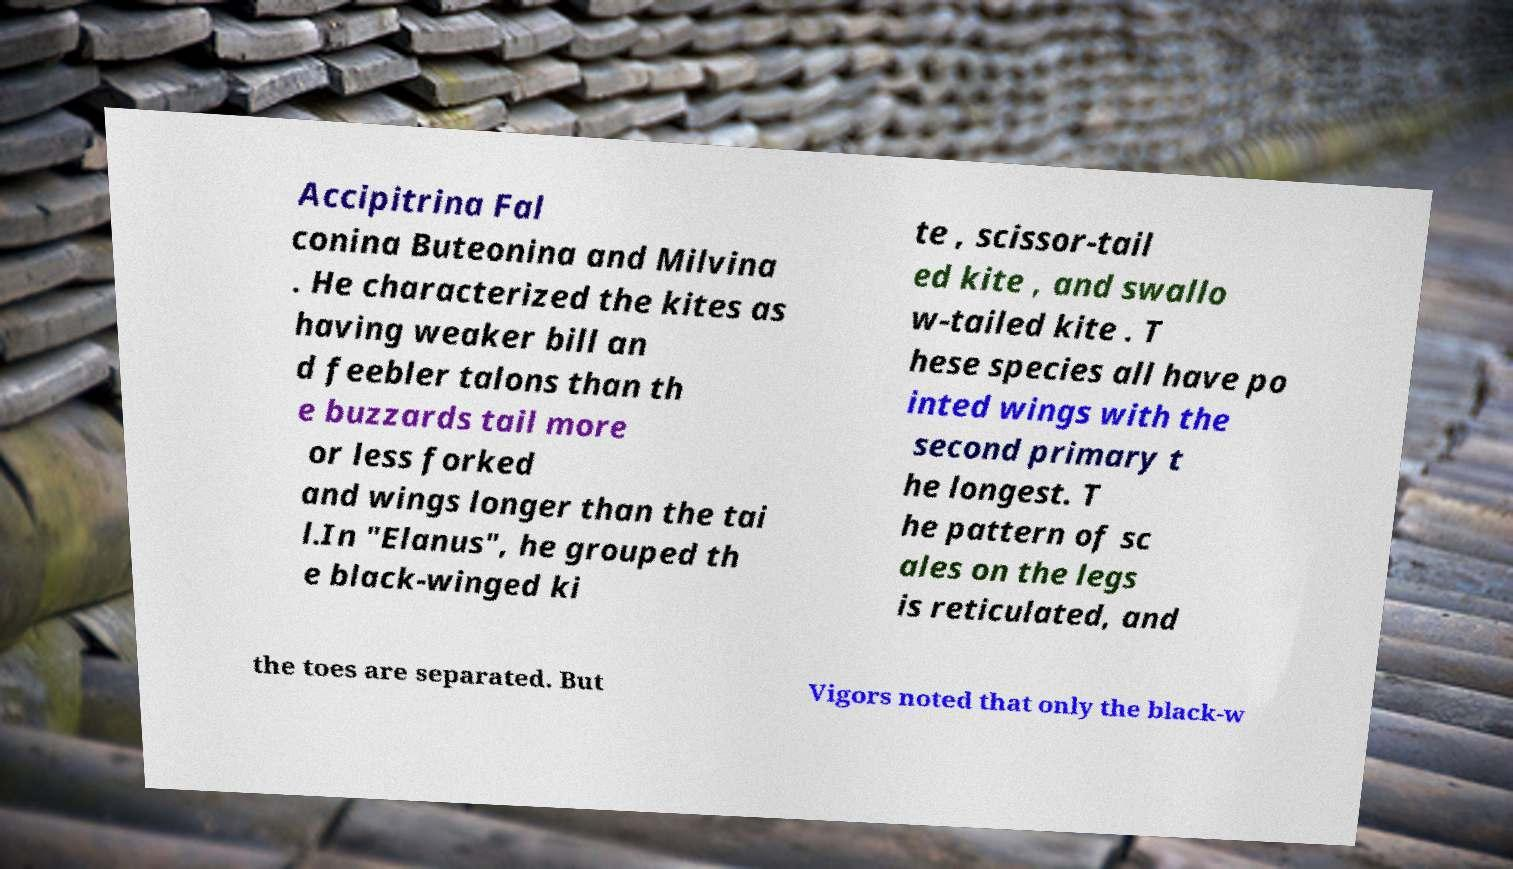Please identify and transcribe the text found in this image. Accipitrina Fal conina Buteonina and Milvina . He characterized the kites as having weaker bill an d feebler talons than th e buzzards tail more or less forked and wings longer than the tai l.In "Elanus", he grouped th e black-winged ki te , scissor-tail ed kite , and swallo w-tailed kite . T hese species all have po inted wings with the second primary t he longest. T he pattern of sc ales on the legs is reticulated, and the toes are separated. But Vigors noted that only the black-w 